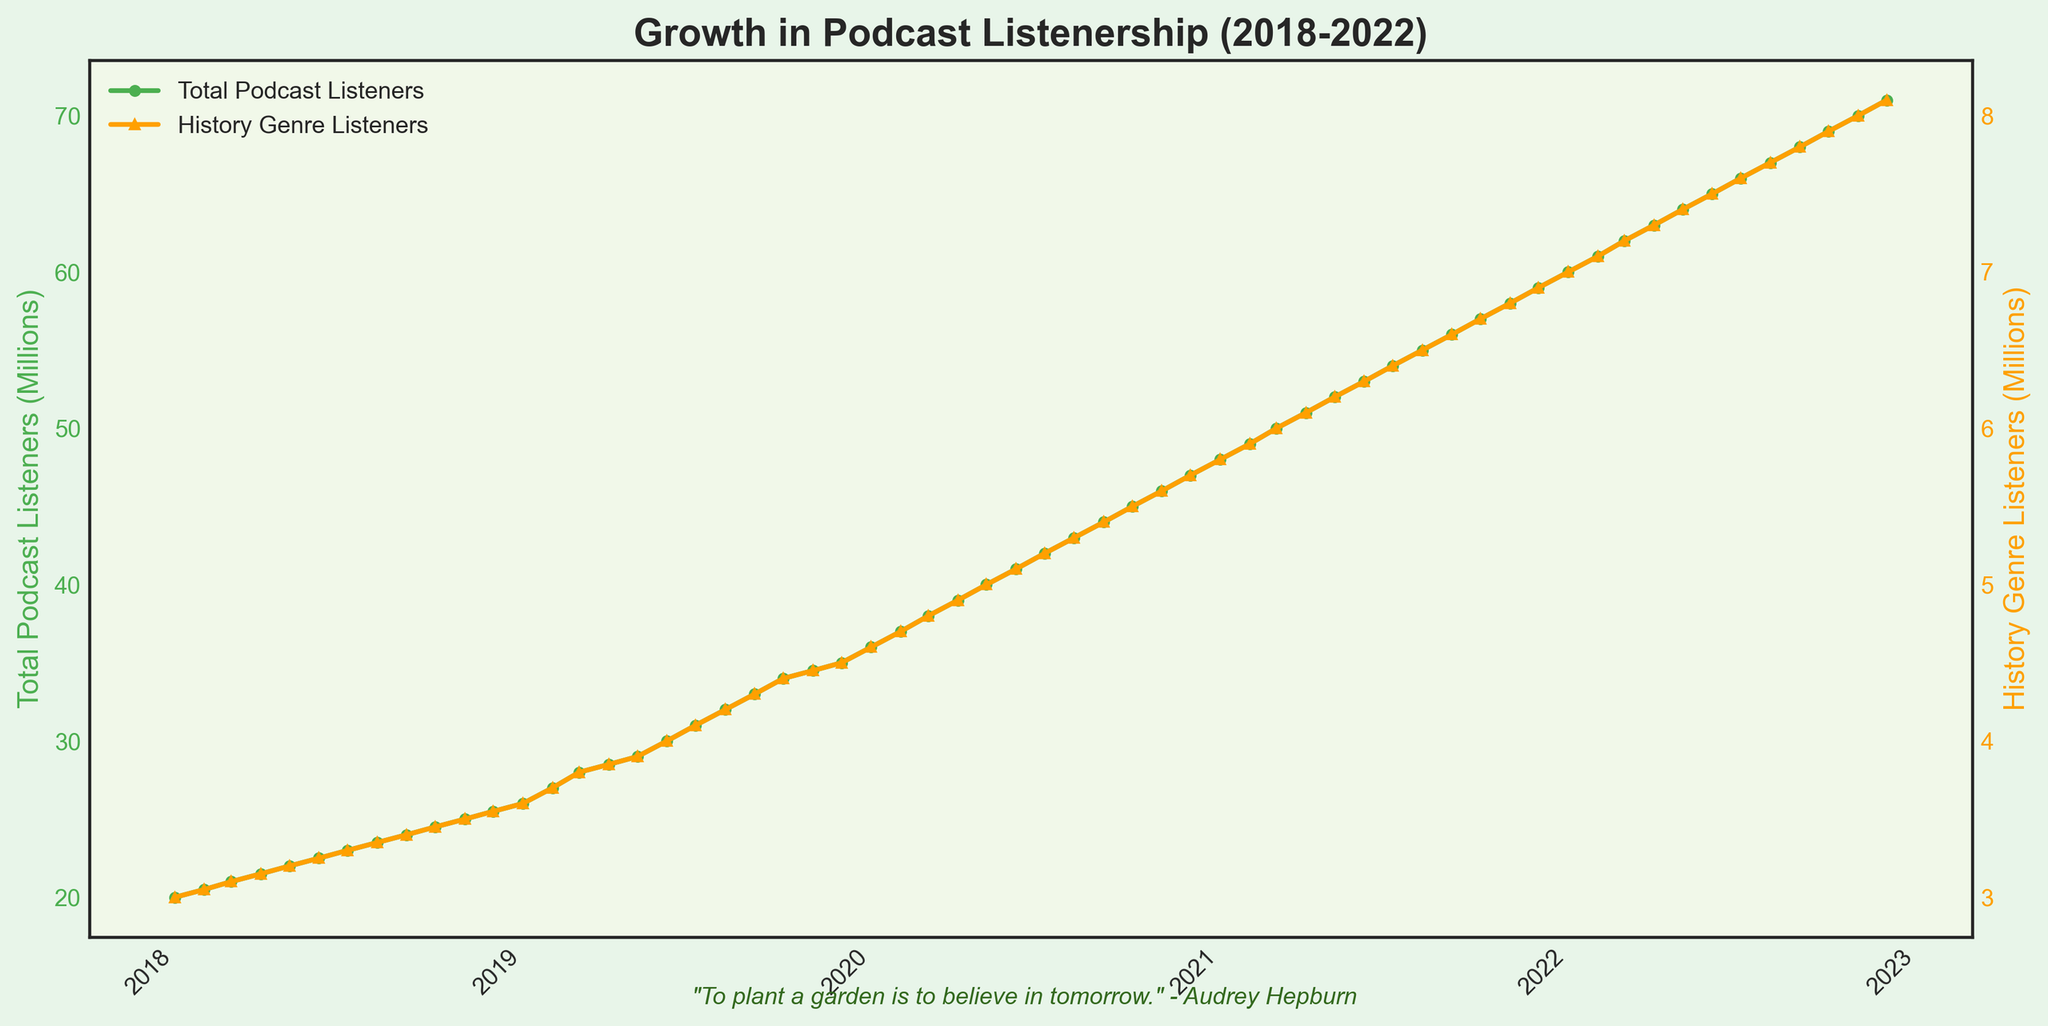What's the title of the plot? The title of the plot is located at the top of the figure, and it's written in bold font.
Answer: Growth in Podcast Listenership (2018-2022) What's the color of the line representing Total Podcast Listeners? The color of the line representing Total Podcast Listeners can be identified by looking at the legend in the plot or the line itself on the graph.
Answer: Green How many History Genre Listeners were there in January 2020? The number of History Genre Listeners in January 2020 is shown on the y-axis corresponding to the orange line at the point labeled "January 2020" on the x-axis.
Answer: 4.6 million By how much did the Total Podcast Listeners increase from January 2019 to January 2022? To determine the increase, subtract the value of Total Podcast Listeners in January 2019 from the value in January 2022. These values can be found by looking at the green line at the respective dates.
Answer: 34 million On which date were the Total Podcast Listeners equal to 40 million? Find the point on the green line where it crosses the 40 million mark on the y-axis and read off the corresponding date on the x-axis.
Answer: May 2020 Compare the growth rate of History Genre Listeners to Total Podcast Listeners over the period. Which one grew faster? Calculate the overall increase for both History Genre Listeners and Total Podcast Listeners from the start to the end date. Compare the differences in values to determine which one grew faster.
Answer: History Genre Listeners What is the y-axis label for History Genre Listeners? The y-axis label for History Genre Listeners can be found on the right side of the figure, indicating the measurement specific to the orange line.
Answer: History Genre Listeners (Millions) Did the number of History Genre Listeners ever decrease between 2018 and 2022? Examine the trend of the orange line throughout the plot to see if it decreases at any point.
Answer: No Which month and year saw the highest number of History Genre Listeners? Locate the peak point on the orange line, find the corresponding date on the x-axis directly below this peak.
Answer: December 2022 